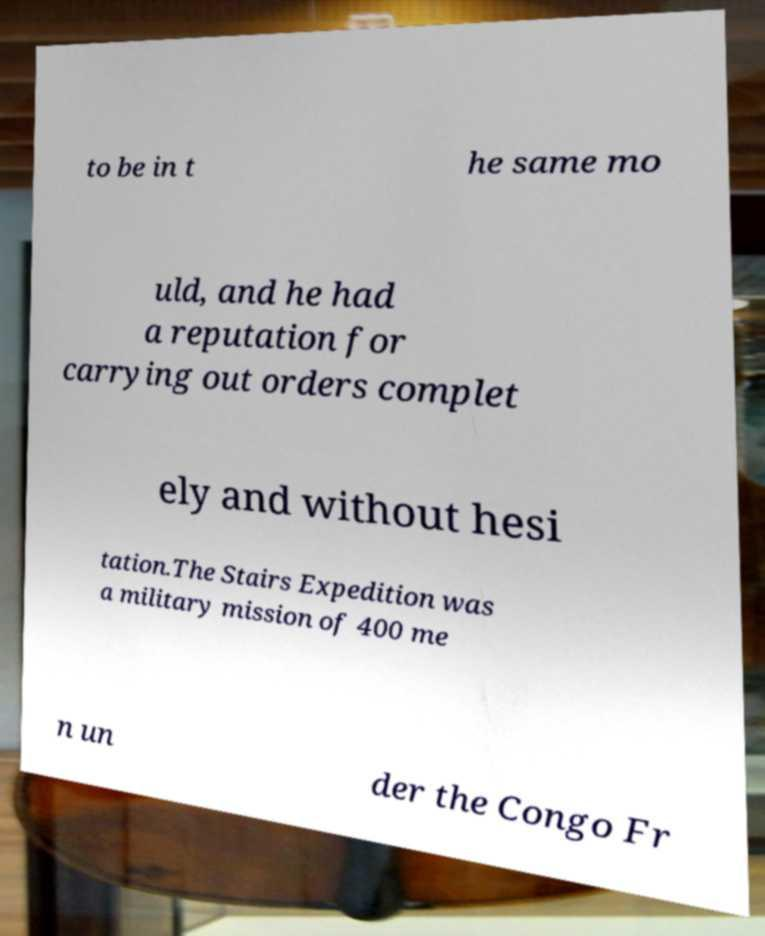For documentation purposes, I need the text within this image transcribed. Could you provide that? to be in t he same mo uld, and he had a reputation for carrying out orders complet ely and without hesi tation.The Stairs Expedition was a military mission of 400 me n un der the Congo Fr 